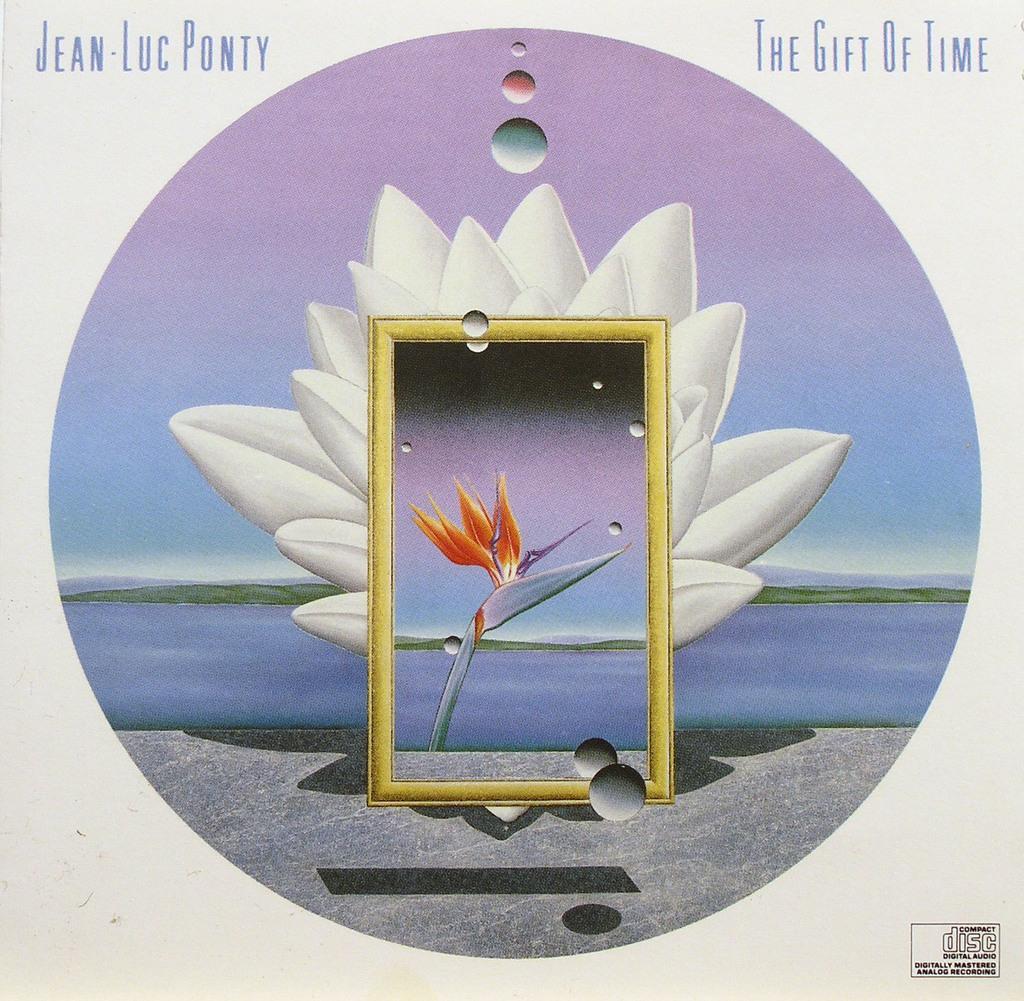Please provide a concise description of this image. In this image I can see the poster. In the poster I can see the flowers which are in white and orange color. In the background I can see the water, grass and the sky. I can also see the text on the poster. 